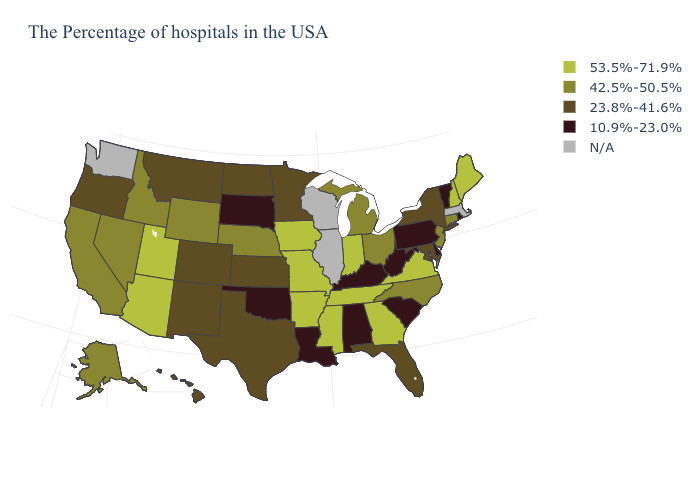Name the states that have a value in the range 23.8%-41.6%?
Write a very short answer. New York, Maryland, Florida, Minnesota, Kansas, Texas, North Dakota, Colorado, New Mexico, Montana, Oregon, Hawaii. Name the states that have a value in the range 42.5%-50.5%?
Quick response, please. Connecticut, New Jersey, North Carolina, Ohio, Michigan, Nebraska, Wyoming, Idaho, Nevada, California, Alaska. Name the states that have a value in the range 53.5%-71.9%?
Keep it brief. Maine, New Hampshire, Virginia, Georgia, Indiana, Tennessee, Mississippi, Missouri, Arkansas, Iowa, Utah, Arizona. What is the value of Nebraska?
Quick response, please. 42.5%-50.5%. What is the lowest value in states that border Florida?
Write a very short answer. 10.9%-23.0%. Among the states that border North Dakota , which have the lowest value?
Be succinct. South Dakota. What is the value of Vermont?
Short answer required. 10.9%-23.0%. What is the value of Wisconsin?
Quick response, please. N/A. What is the value of Utah?
Concise answer only. 53.5%-71.9%. What is the highest value in the South ?
Short answer required. 53.5%-71.9%. Which states have the lowest value in the USA?
Quick response, please. Rhode Island, Vermont, Delaware, Pennsylvania, South Carolina, West Virginia, Kentucky, Alabama, Louisiana, Oklahoma, South Dakota. Does the first symbol in the legend represent the smallest category?
Concise answer only. No. Does Florida have the lowest value in the South?
Answer briefly. No. Does Arizona have the highest value in the West?
Give a very brief answer. Yes. What is the value of Connecticut?
Concise answer only. 42.5%-50.5%. 